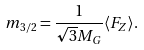<formula> <loc_0><loc_0><loc_500><loc_500>m _ { 3 / 2 } = \frac { 1 } { \sqrt { 3 } M _ { G } } \langle F _ { Z } \rangle .</formula> 